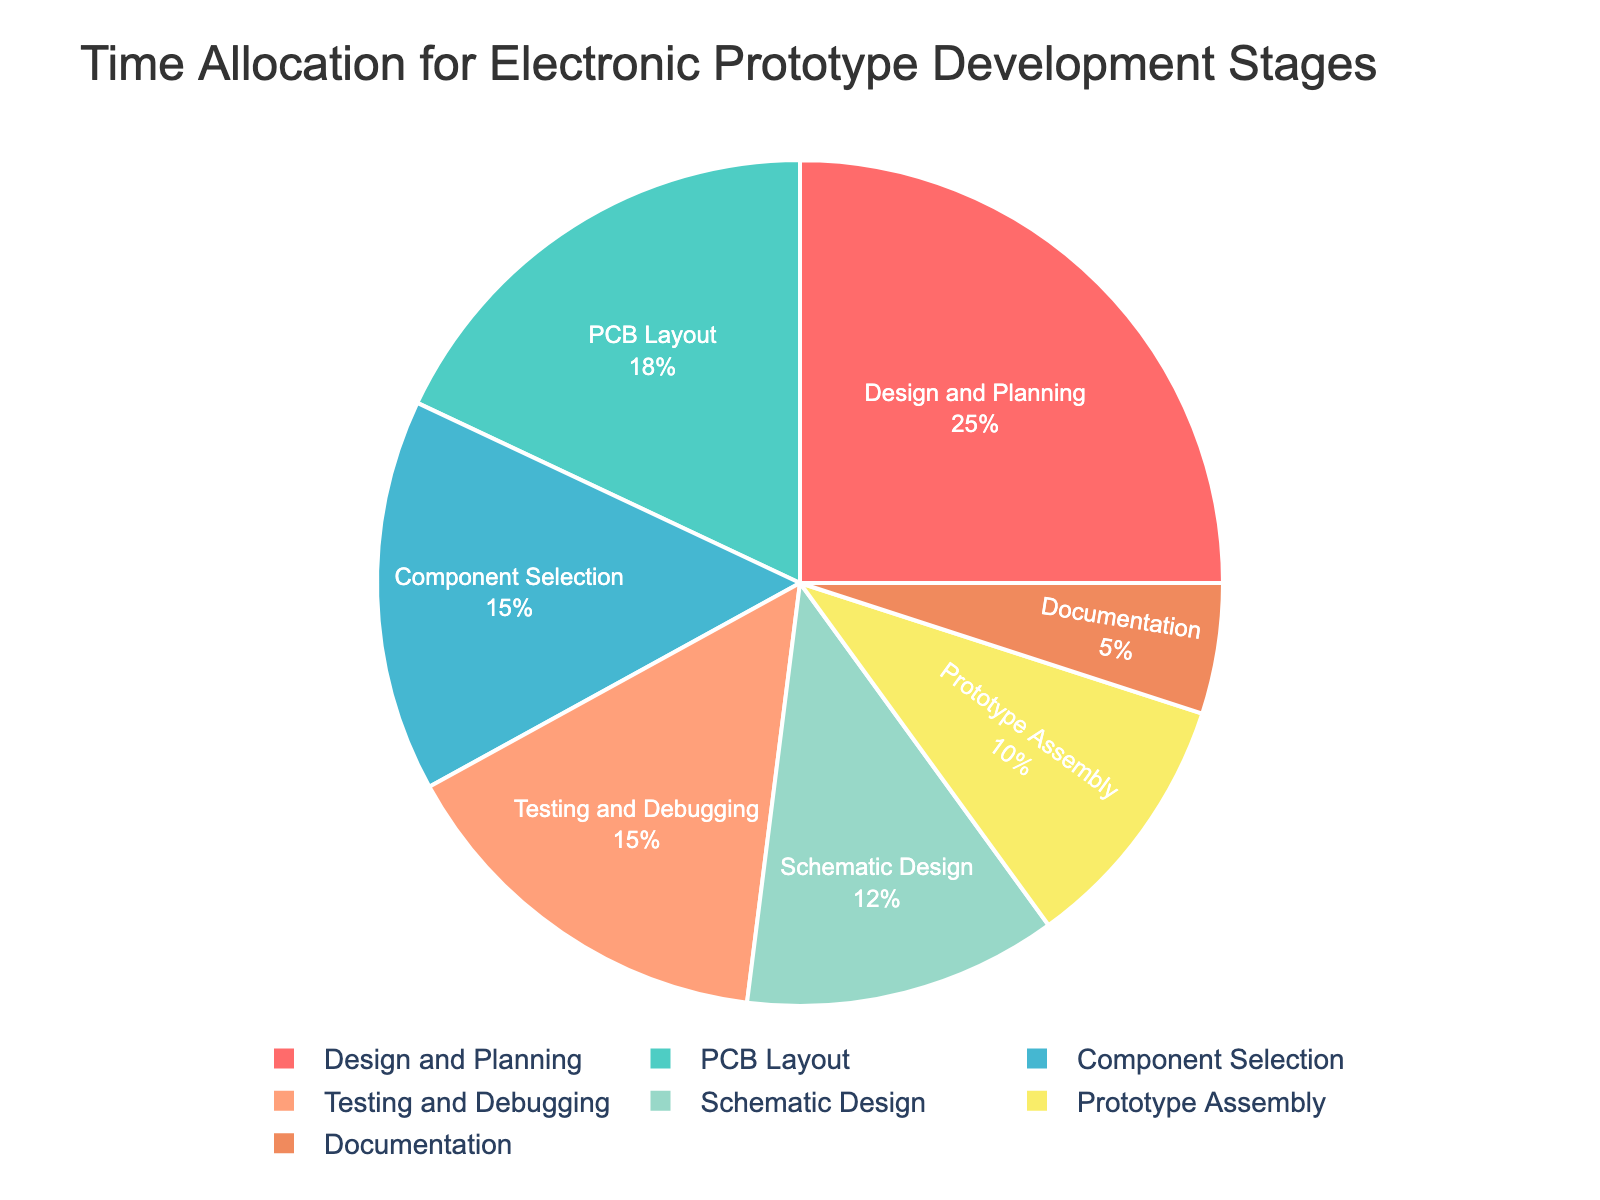Which stage takes up the largest percentage of time? The stage with the largest percentage slice in the pie chart is the Design and Planning stage. It occupies 25% of the total time allocation.
Answer: Design and Planning What is the combined percentage of time spent on Testing and Debugging and Component Selection? To get the combined percentage, add the percentage of time spent on Testing and Debugging (15%) and Component Selection (15%).
Answer: 30% How does the time allocated to Prototype Assembly compare to Documentation? The pie chart shows that Prototype Assembly takes up 10% of the time, while Documentation takes up 5%.
Answer: Prototype Assembly takes double the time of Documentation Which stages have an equal percentage of time allocation, and what is that percentage? The pie chart indicates that both Component Selection and Testing and Debugging have the same time allocation, which is 15%.
Answer: Component Selection and Testing and Debugging, 15% How much more time is allocated to PCB Layout compared to Schematic Design? The pie chart shows PCB Layout with 18% and Schematic Design with 12%. Subtracting these gives the difference.
Answer: 6% What is the total percentage of time allocated to stages that are primarily involved in physical construction (e.g., PCB Layout, Prototype Assembly)? Add the percentages for PCB Layout (18%) and Prototype Assembly (10%).
Answer: 28% Which color represents the Design and Planning stage in the pie chart? Design and Planning is represented by a vivid red segment in the pie chart.
Answer: Red Is there any segment in the pie chart that takes exactly half the time of PCB Layout? If yes, which one? PCB Layout takes 18%, and an exact half of that is 9%. The closest segment is Prototype Assembly, which takes 10%, slightly more than half.
Answer: No Considering the color scheme, which stage is represented by a shade of green? The pie chart uses a shade of green for Component Selection.
Answer: Component Selection What is the average percentage of time allocated to the stages excluding Documentation? To find the average, sum the percentages of the six other stages (25% + 15% + 12% + 18% + 10% + 15%) and divide by 6. The total is 95%, and dividing by 6 gives approximately 15.83%.
Answer: 15.83% 